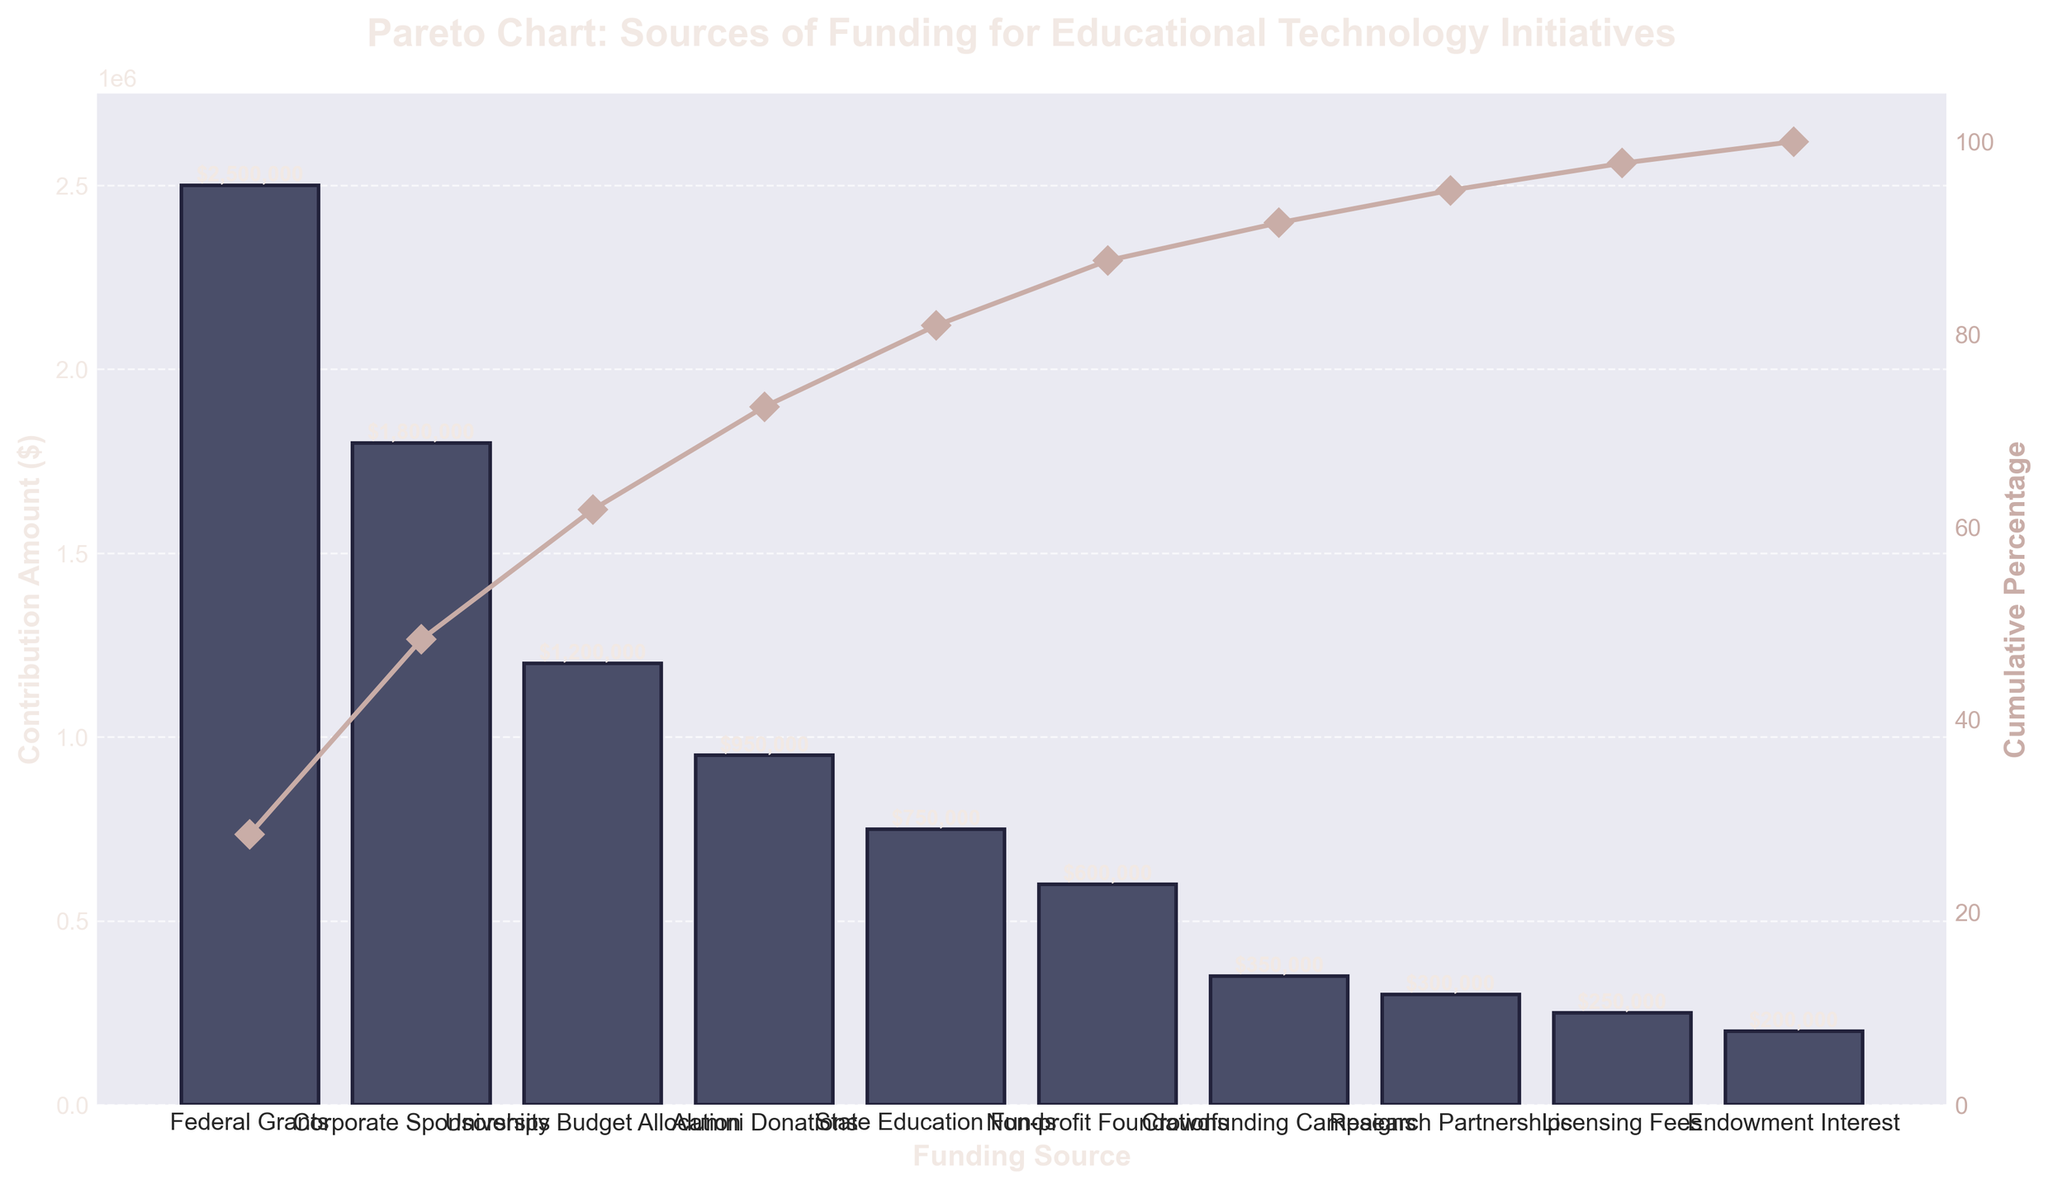Who provides the highest contribution amount for educational technology initiatives? According to the Pareto chart, "Federal Grants" is the funding source with the highest contribution, denoted by the tallest bar.
Answer: Federal Grants What is the total contribution amount from the top three funding sources? The top three funding sources are "Federal Grants," "Corporate Sponsorships," and "University Budget Allocation." Their contribution amounts are $2,500,000, $1,800,000, and $1,200,000, respectively. Summing them up gives $2,500,000 + $1,800,000 + $1,200,000 = $5,500,000.
Answer: $5,500,000 What is the cumulative percentage after including contributions from "Alumni Donations"? "Alumni Donations" is the fourth source. The cumulative percentages at this point are: Federal Grants (41.67%), Corporate Sponsorships (~71.67%), University Budget Allocation (~91.67%), and Alumni Donations (~108.33%). The cumulative percentage reaches over 100%, but exact interpretation depends on the chart axis scaling.
Answer: ~108.33% Which funding source provides a contribution closest to $1,000,000? "Alumni Donations" provide a contribution close to $950,000, which is nearest to $1,000,000 as per the chart.
Answer: Alumni Donations How much more does "Corporate Sponsorships" contribute compared to "State Education Funds"? "Corporate Sponsorships" contribute $1,800,000, while "State Education Funds" contribute $750,000. The difference is $1,800,000 - $750,000 = $1,050,000.
Answer: $1,050,000 What percentage of the total contributions is covered by the "University Budget Allocation" alone? The "University Budget Allocation" contribution is $1,200,000. The total contributions sum is $8,900,000 (summing all values). The percentage is ($1,200,000 / $8,900,000) * 100 ≈ 13.48%.
Answer: 13.48% Between which two funding sources does the largest drop in contribution amount occur? The largest drop in contribution amount is between "Corporate Sponsorships" ($1,800,000) and "University Budget Allocation" ($1,200,000) with a difference of $600,000.
Answer: Corporate Sponsorships and University Budget Allocation How many funding sources together make up at least 80% of the total contributions? Summing the cumulative percentages from the chart: Federal Grants (41.67%) + Corporate Sponsorships (31.67%) = 73.34% => Not sufficient. Adding University Budget Allocation (20%) => 93.34% => First three sources are enough to exceed 80%.
Answer: 3 What is the difference in contribution amounts between the highest and lowest funding sources? The highest contribution is from "Federal Grants" ($2,500,000) and the lowest is from "Endowment Interest" ($200,000). The difference is $2,500,000 - $200,000 = $2,300,000.
Answer: $2,300,000 What is the main insight provided by this Pareto chart regarding educational technology funding? The Pareto chart indicates that a significant amount of funding is concentrated in a few top sources. Federal Grants, Corporate Sponsorships, and University Budget Allocation together contribute more than 80% of total funding, highlighting the importance of these major funding sources.
Answer: Major funding sources dominate 